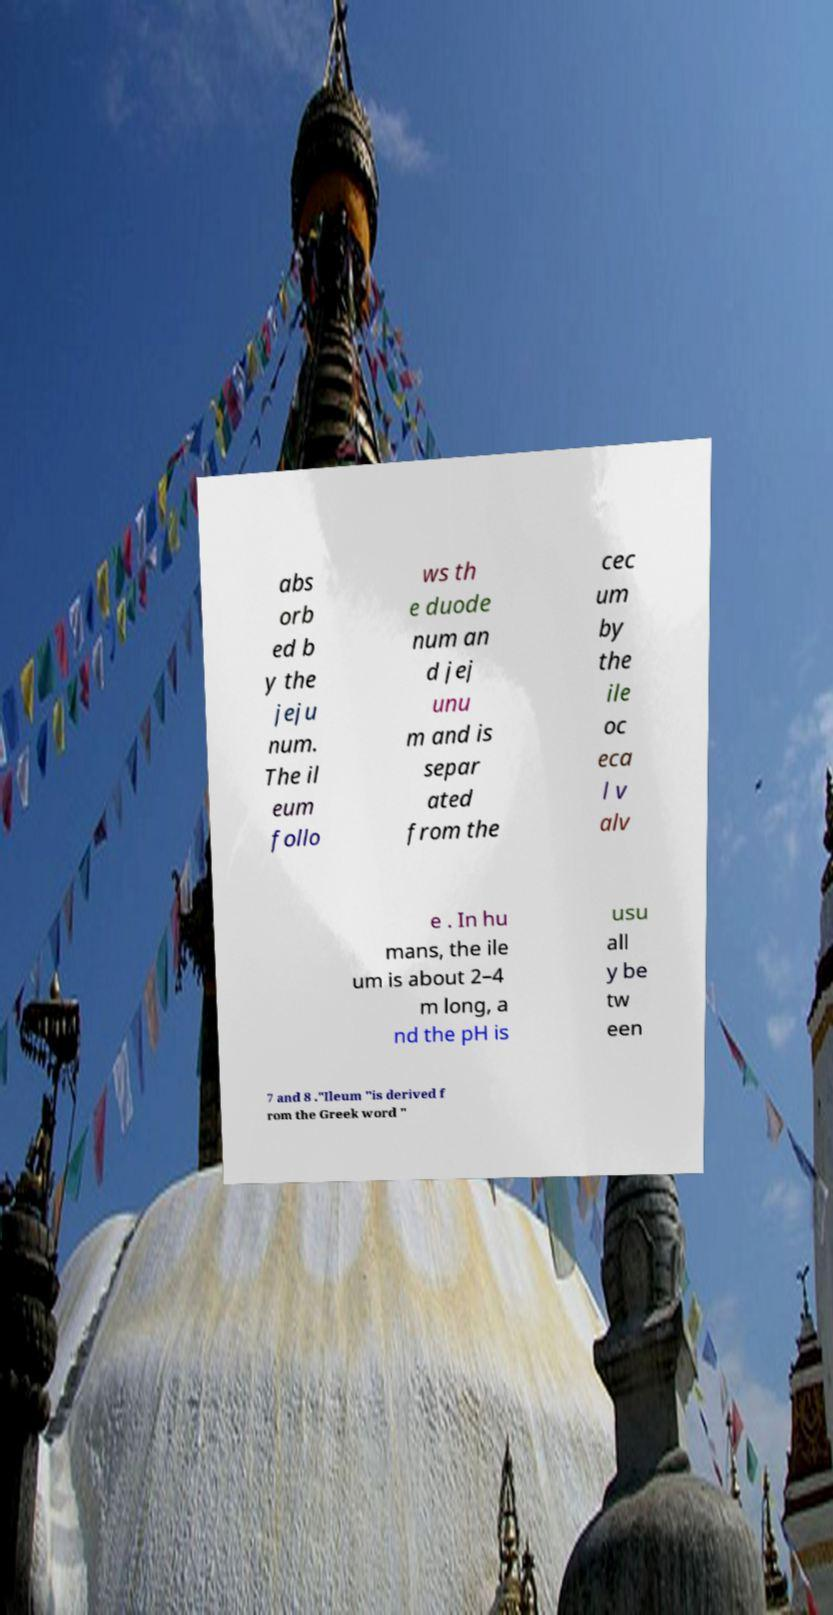For documentation purposes, I need the text within this image transcribed. Could you provide that? abs orb ed b y the jeju num. The il eum follo ws th e duode num an d jej unu m and is separ ated from the cec um by the ile oc eca l v alv e . In hu mans, the ile um is about 2–4 m long, a nd the pH is usu all y be tw een 7 and 8 ."Ileum "is derived f rom the Greek word " 